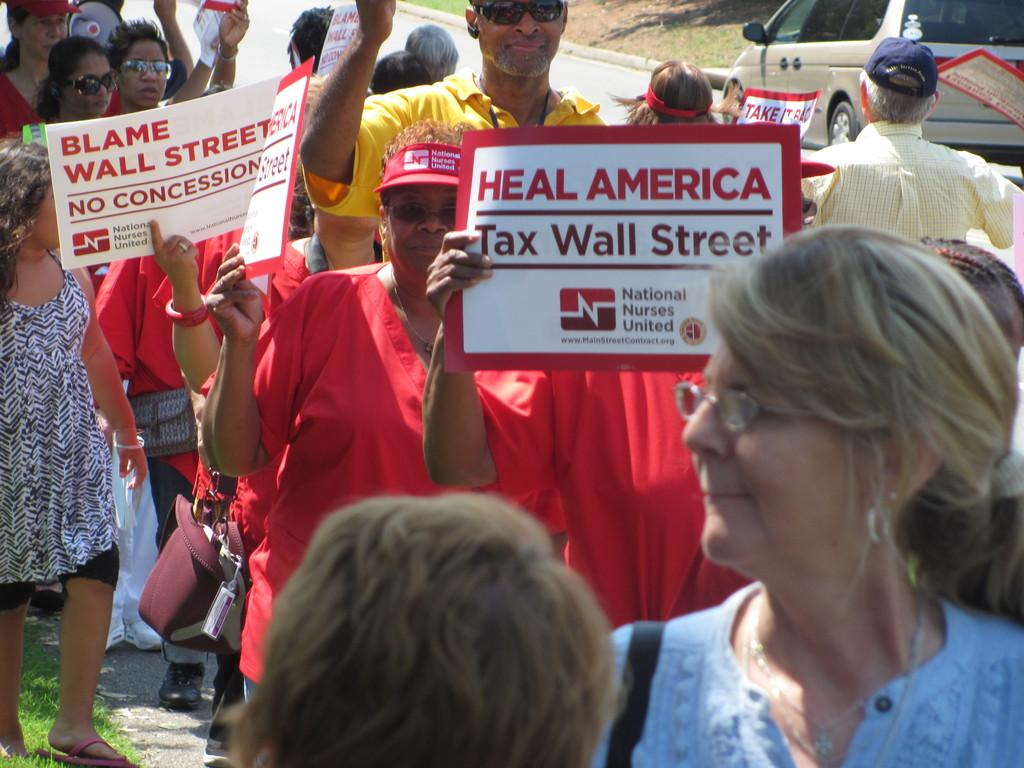How many people are in the image? There is a group of people in the image. Where are the people located in the image? The people are standing on the road. What are some of the people holding in the image? Some of the people are holding papers and boards with text. What else can be seen in the image besides the people? There is a car visible in the image, and it is on the road. Are there any slaves visible in the image? There is no mention of slaves in the image, and the term "slave" is not relevant to the context of the image. 